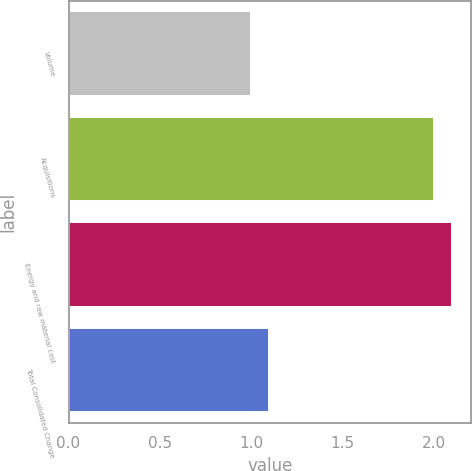<chart> <loc_0><loc_0><loc_500><loc_500><bar_chart><fcel>Volume<fcel>Acquisitions<fcel>Energy and raw material cost<fcel>Total Consolidated Change<nl><fcel>1<fcel>2<fcel>2.1<fcel>1.1<nl></chart> 